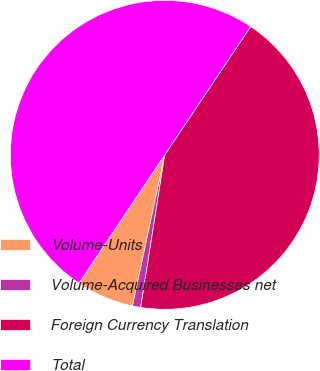Convert chart to OTSL. <chart><loc_0><loc_0><loc_500><loc_500><pie_chart><fcel>Volume-Units<fcel>Volume-Acquired Businesses net<fcel>Foreign Currency Translation<fcel>Total<nl><fcel>6.03%<fcel>0.86%<fcel>43.1%<fcel>50.0%<nl></chart> 